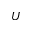<formula> <loc_0><loc_0><loc_500><loc_500>U</formula> 